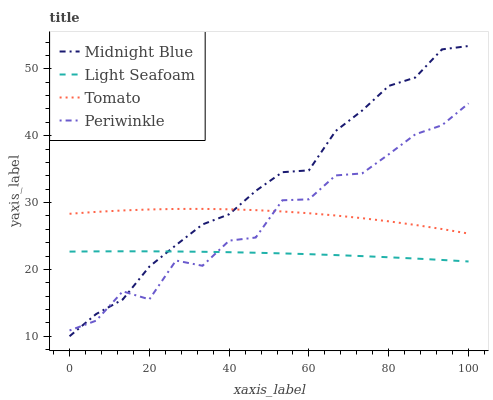Does Light Seafoam have the minimum area under the curve?
Answer yes or no. Yes. Does Midnight Blue have the maximum area under the curve?
Answer yes or no. Yes. Does Periwinkle have the minimum area under the curve?
Answer yes or no. No. Does Periwinkle have the maximum area under the curve?
Answer yes or no. No. Is Light Seafoam the smoothest?
Answer yes or no. Yes. Is Periwinkle the roughest?
Answer yes or no. Yes. Is Periwinkle the smoothest?
Answer yes or no. No. Is Light Seafoam the roughest?
Answer yes or no. No. Does Midnight Blue have the lowest value?
Answer yes or no. Yes. Does Light Seafoam have the lowest value?
Answer yes or no. No. Does Midnight Blue have the highest value?
Answer yes or no. Yes. Does Periwinkle have the highest value?
Answer yes or no. No. Is Light Seafoam less than Tomato?
Answer yes or no. Yes. Is Tomato greater than Light Seafoam?
Answer yes or no. Yes. Does Midnight Blue intersect Periwinkle?
Answer yes or no. Yes. Is Midnight Blue less than Periwinkle?
Answer yes or no. No. Is Midnight Blue greater than Periwinkle?
Answer yes or no. No. Does Light Seafoam intersect Tomato?
Answer yes or no. No. 